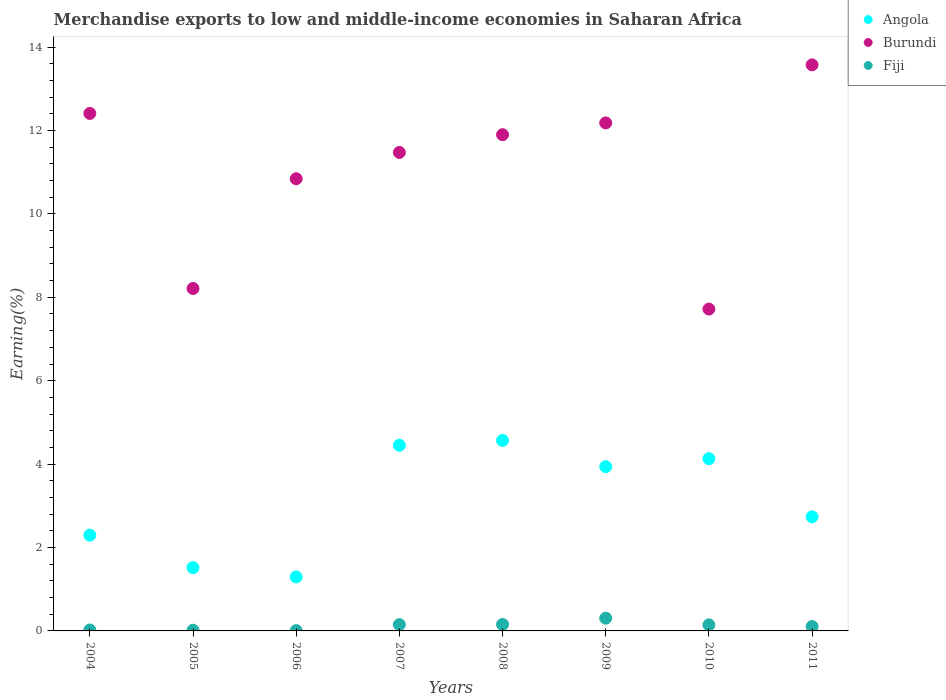What is the percentage of amount earned from merchandise exports in Fiji in 2009?
Your answer should be very brief. 0.31. Across all years, what is the maximum percentage of amount earned from merchandise exports in Fiji?
Ensure brevity in your answer.  0.31. Across all years, what is the minimum percentage of amount earned from merchandise exports in Fiji?
Give a very brief answer. 0.01. What is the total percentage of amount earned from merchandise exports in Fiji in the graph?
Offer a very short reply. 0.91. What is the difference between the percentage of amount earned from merchandise exports in Angola in 2005 and that in 2010?
Make the answer very short. -2.61. What is the difference between the percentage of amount earned from merchandise exports in Burundi in 2011 and the percentage of amount earned from merchandise exports in Fiji in 2007?
Your answer should be very brief. 13.42. What is the average percentage of amount earned from merchandise exports in Fiji per year?
Your answer should be very brief. 0.11. In the year 2007, what is the difference between the percentage of amount earned from merchandise exports in Angola and percentage of amount earned from merchandise exports in Burundi?
Make the answer very short. -7.02. What is the ratio of the percentage of amount earned from merchandise exports in Angola in 2004 to that in 2010?
Offer a very short reply. 0.56. What is the difference between the highest and the second highest percentage of amount earned from merchandise exports in Angola?
Offer a very short reply. 0.11. What is the difference between the highest and the lowest percentage of amount earned from merchandise exports in Fiji?
Your answer should be very brief. 0.3. In how many years, is the percentage of amount earned from merchandise exports in Angola greater than the average percentage of amount earned from merchandise exports in Angola taken over all years?
Your answer should be very brief. 4. Is it the case that in every year, the sum of the percentage of amount earned from merchandise exports in Fiji and percentage of amount earned from merchandise exports in Burundi  is greater than the percentage of amount earned from merchandise exports in Angola?
Your response must be concise. Yes. Does the percentage of amount earned from merchandise exports in Burundi monotonically increase over the years?
Your answer should be very brief. No. How many dotlines are there?
Give a very brief answer. 3. How many years are there in the graph?
Offer a terse response. 8. What is the difference between two consecutive major ticks on the Y-axis?
Ensure brevity in your answer.  2. Are the values on the major ticks of Y-axis written in scientific E-notation?
Your response must be concise. No. Where does the legend appear in the graph?
Keep it short and to the point. Top right. How are the legend labels stacked?
Offer a terse response. Vertical. What is the title of the graph?
Make the answer very short. Merchandise exports to low and middle-income economies in Saharan Africa. What is the label or title of the Y-axis?
Make the answer very short. Earning(%). What is the Earning(%) in Angola in 2004?
Keep it short and to the point. 2.3. What is the Earning(%) in Burundi in 2004?
Provide a succinct answer. 12.41. What is the Earning(%) in Fiji in 2004?
Provide a succinct answer. 0.02. What is the Earning(%) in Angola in 2005?
Provide a succinct answer. 1.52. What is the Earning(%) in Burundi in 2005?
Keep it short and to the point. 8.21. What is the Earning(%) of Fiji in 2005?
Your response must be concise. 0.02. What is the Earning(%) in Angola in 2006?
Provide a short and direct response. 1.3. What is the Earning(%) in Burundi in 2006?
Offer a terse response. 10.84. What is the Earning(%) in Fiji in 2006?
Keep it short and to the point. 0.01. What is the Earning(%) of Angola in 2007?
Provide a succinct answer. 4.45. What is the Earning(%) in Burundi in 2007?
Offer a very short reply. 11.47. What is the Earning(%) of Fiji in 2007?
Your response must be concise. 0.15. What is the Earning(%) in Angola in 2008?
Your answer should be very brief. 4.57. What is the Earning(%) in Burundi in 2008?
Ensure brevity in your answer.  11.9. What is the Earning(%) in Fiji in 2008?
Provide a short and direct response. 0.16. What is the Earning(%) of Angola in 2009?
Give a very brief answer. 3.94. What is the Earning(%) of Burundi in 2009?
Offer a terse response. 12.18. What is the Earning(%) of Fiji in 2009?
Your response must be concise. 0.31. What is the Earning(%) in Angola in 2010?
Keep it short and to the point. 4.13. What is the Earning(%) of Burundi in 2010?
Your answer should be very brief. 7.72. What is the Earning(%) of Fiji in 2010?
Provide a succinct answer. 0.15. What is the Earning(%) of Angola in 2011?
Your answer should be very brief. 2.74. What is the Earning(%) of Burundi in 2011?
Your response must be concise. 13.57. What is the Earning(%) of Fiji in 2011?
Your answer should be very brief. 0.11. Across all years, what is the maximum Earning(%) in Angola?
Offer a terse response. 4.57. Across all years, what is the maximum Earning(%) in Burundi?
Provide a succinct answer. 13.57. Across all years, what is the maximum Earning(%) of Fiji?
Your answer should be compact. 0.31. Across all years, what is the minimum Earning(%) in Angola?
Your answer should be compact. 1.3. Across all years, what is the minimum Earning(%) in Burundi?
Provide a succinct answer. 7.72. Across all years, what is the minimum Earning(%) of Fiji?
Your answer should be compact. 0.01. What is the total Earning(%) in Angola in the graph?
Keep it short and to the point. 24.94. What is the total Earning(%) in Burundi in the graph?
Your answer should be very brief. 88.31. What is the total Earning(%) in Fiji in the graph?
Provide a short and direct response. 0.91. What is the difference between the Earning(%) in Angola in 2004 and that in 2005?
Your response must be concise. 0.78. What is the difference between the Earning(%) of Burundi in 2004 and that in 2005?
Your answer should be compact. 4.2. What is the difference between the Earning(%) in Fiji in 2004 and that in 2005?
Provide a short and direct response. 0.01. What is the difference between the Earning(%) in Angola in 2004 and that in 2006?
Give a very brief answer. 1. What is the difference between the Earning(%) in Burundi in 2004 and that in 2006?
Your answer should be compact. 1.57. What is the difference between the Earning(%) in Fiji in 2004 and that in 2006?
Provide a succinct answer. 0.01. What is the difference between the Earning(%) of Angola in 2004 and that in 2007?
Keep it short and to the point. -2.16. What is the difference between the Earning(%) in Burundi in 2004 and that in 2007?
Your answer should be very brief. 0.94. What is the difference between the Earning(%) in Fiji in 2004 and that in 2007?
Make the answer very short. -0.13. What is the difference between the Earning(%) in Angola in 2004 and that in 2008?
Give a very brief answer. -2.27. What is the difference between the Earning(%) of Burundi in 2004 and that in 2008?
Give a very brief answer. 0.51. What is the difference between the Earning(%) in Fiji in 2004 and that in 2008?
Offer a very short reply. -0.13. What is the difference between the Earning(%) in Angola in 2004 and that in 2009?
Ensure brevity in your answer.  -1.64. What is the difference between the Earning(%) of Burundi in 2004 and that in 2009?
Your answer should be very brief. 0.23. What is the difference between the Earning(%) in Fiji in 2004 and that in 2009?
Your response must be concise. -0.28. What is the difference between the Earning(%) of Angola in 2004 and that in 2010?
Your response must be concise. -1.83. What is the difference between the Earning(%) in Burundi in 2004 and that in 2010?
Make the answer very short. 4.69. What is the difference between the Earning(%) in Fiji in 2004 and that in 2010?
Ensure brevity in your answer.  -0.12. What is the difference between the Earning(%) of Angola in 2004 and that in 2011?
Offer a very short reply. -0.44. What is the difference between the Earning(%) in Burundi in 2004 and that in 2011?
Provide a succinct answer. -1.17. What is the difference between the Earning(%) in Fiji in 2004 and that in 2011?
Offer a very short reply. -0.08. What is the difference between the Earning(%) in Angola in 2005 and that in 2006?
Your answer should be very brief. 0.22. What is the difference between the Earning(%) of Burundi in 2005 and that in 2006?
Your answer should be very brief. -2.63. What is the difference between the Earning(%) of Fiji in 2005 and that in 2006?
Ensure brevity in your answer.  0.01. What is the difference between the Earning(%) in Angola in 2005 and that in 2007?
Give a very brief answer. -2.93. What is the difference between the Earning(%) in Burundi in 2005 and that in 2007?
Provide a short and direct response. -3.26. What is the difference between the Earning(%) of Fiji in 2005 and that in 2007?
Give a very brief answer. -0.13. What is the difference between the Earning(%) in Angola in 2005 and that in 2008?
Your response must be concise. -3.05. What is the difference between the Earning(%) of Burundi in 2005 and that in 2008?
Provide a short and direct response. -3.69. What is the difference between the Earning(%) of Fiji in 2005 and that in 2008?
Your answer should be very brief. -0.14. What is the difference between the Earning(%) of Angola in 2005 and that in 2009?
Offer a very short reply. -2.42. What is the difference between the Earning(%) in Burundi in 2005 and that in 2009?
Offer a terse response. -3.97. What is the difference between the Earning(%) in Fiji in 2005 and that in 2009?
Ensure brevity in your answer.  -0.29. What is the difference between the Earning(%) in Angola in 2005 and that in 2010?
Give a very brief answer. -2.61. What is the difference between the Earning(%) of Burundi in 2005 and that in 2010?
Provide a succinct answer. 0.49. What is the difference between the Earning(%) of Fiji in 2005 and that in 2010?
Your answer should be compact. -0.13. What is the difference between the Earning(%) of Angola in 2005 and that in 2011?
Make the answer very short. -1.22. What is the difference between the Earning(%) in Burundi in 2005 and that in 2011?
Offer a very short reply. -5.36. What is the difference between the Earning(%) in Fiji in 2005 and that in 2011?
Give a very brief answer. -0.09. What is the difference between the Earning(%) in Angola in 2006 and that in 2007?
Your response must be concise. -3.16. What is the difference between the Earning(%) of Burundi in 2006 and that in 2007?
Give a very brief answer. -0.63. What is the difference between the Earning(%) in Fiji in 2006 and that in 2007?
Keep it short and to the point. -0.14. What is the difference between the Earning(%) of Angola in 2006 and that in 2008?
Offer a very short reply. -3.27. What is the difference between the Earning(%) of Burundi in 2006 and that in 2008?
Your answer should be compact. -1.06. What is the difference between the Earning(%) in Fiji in 2006 and that in 2008?
Ensure brevity in your answer.  -0.15. What is the difference between the Earning(%) of Angola in 2006 and that in 2009?
Offer a terse response. -2.64. What is the difference between the Earning(%) of Burundi in 2006 and that in 2009?
Make the answer very short. -1.34. What is the difference between the Earning(%) of Fiji in 2006 and that in 2009?
Provide a succinct answer. -0.3. What is the difference between the Earning(%) in Angola in 2006 and that in 2010?
Your response must be concise. -2.84. What is the difference between the Earning(%) in Burundi in 2006 and that in 2010?
Your response must be concise. 3.13. What is the difference between the Earning(%) of Fiji in 2006 and that in 2010?
Your answer should be compact. -0.14. What is the difference between the Earning(%) of Angola in 2006 and that in 2011?
Make the answer very short. -1.44. What is the difference between the Earning(%) of Burundi in 2006 and that in 2011?
Give a very brief answer. -2.73. What is the difference between the Earning(%) in Fiji in 2006 and that in 2011?
Your answer should be compact. -0.1. What is the difference between the Earning(%) in Angola in 2007 and that in 2008?
Ensure brevity in your answer.  -0.11. What is the difference between the Earning(%) in Burundi in 2007 and that in 2008?
Your answer should be compact. -0.43. What is the difference between the Earning(%) of Fiji in 2007 and that in 2008?
Provide a succinct answer. -0. What is the difference between the Earning(%) in Angola in 2007 and that in 2009?
Offer a very short reply. 0.51. What is the difference between the Earning(%) in Burundi in 2007 and that in 2009?
Keep it short and to the point. -0.71. What is the difference between the Earning(%) of Fiji in 2007 and that in 2009?
Provide a succinct answer. -0.15. What is the difference between the Earning(%) of Angola in 2007 and that in 2010?
Give a very brief answer. 0.32. What is the difference between the Earning(%) in Burundi in 2007 and that in 2010?
Offer a terse response. 3.76. What is the difference between the Earning(%) in Fiji in 2007 and that in 2010?
Your answer should be very brief. 0. What is the difference between the Earning(%) in Angola in 2007 and that in 2011?
Your answer should be compact. 1.72. What is the difference between the Earning(%) in Burundi in 2007 and that in 2011?
Keep it short and to the point. -2.1. What is the difference between the Earning(%) in Fiji in 2007 and that in 2011?
Make the answer very short. 0.05. What is the difference between the Earning(%) of Angola in 2008 and that in 2009?
Your answer should be very brief. 0.63. What is the difference between the Earning(%) of Burundi in 2008 and that in 2009?
Provide a short and direct response. -0.28. What is the difference between the Earning(%) in Angola in 2008 and that in 2010?
Your response must be concise. 0.44. What is the difference between the Earning(%) in Burundi in 2008 and that in 2010?
Your answer should be very brief. 4.18. What is the difference between the Earning(%) in Fiji in 2008 and that in 2010?
Your answer should be very brief. 0.01. What is the difference between the Earning(%) of Angola in 2008 and that in 2011?
Your answer should be compact. 1.83. What is the difference between the Earning(%) in Burundi in 2008 and that in 2011?
Offer a terse response. -1.67. What is the difference between the Earning(%) in Fiji in 2008 and that in 2011?
Ensure brevity in your answer.  0.05. What is the difference between the Earning(%) of Angola in 2009 and that in 2010?
Your response must be concise. -0.19. What is the difference between the Earning(%) in Burundi in 2009 and that in 2010?
Keep it short and to the point. 4.46. What is the difference between the Earning(%) in Fiji in 2009 and that in 2010?
Your response must be concise. 0.16. What is the difference between the Earning(%) in Angola in 2009 and that in 2011?
Provide a short and direct response. 1.2. What is the difference between the Earning(%) in Burundi in 2009 and that in 2011?
Your response must be concise. -1.39. What is the difference between the Earning(%) of Fiji in 2009 and that in 2011?
Your answer should be very brief. 0.2. What is the difference between the Earning(%) in Angola in 2010 and that in 2011?
Offer a terse response. 1.39. What is the difference between the Earning(%) in Burundi in 2010 and that in 2011?
Provide a succinct answer. -5.86. What is the difference between the Earning(%) in Fiji in 2010 and that in 2011?
Your answer should be compact. 0.04. What is the difference between the Earning(%) in Angola in 2004 and the Earning(%) in Burundi in 2005?
Offer a terse response. -5.92. What is the difference between the Earning(%) of Angola in 2004 and the Earning(%) of Fiji in 2005?
Give a very brief answer. 2.28. What is the difference between the Earning(%) in Burundi in 2004 and the Earning(%) in Fiji in 2005?
Your answer should be very brief. 12.39. What is the difference between the Earning(%) in Angola in 2004 and the Earning(%) in Burundi in 2006?
Offer a terse response. -8.55. What is the difference between the Earning(%) of Angola in 2004 and the Earning(%) of Fiji in 2006?
Your answer should be very brief. 2.29. What is the difference between the Earning(%) of Burundi in 2004 and the Earning(%) of Fiji in 2006?
Make the answer very short. 12.4. What is the difference between the Earning(%) of Angola in 2004 and the Earning(%) of Burundi in 2007?
Offer a very short reply. -9.18. What is the difference between the Earning(%) in Angola in 2004 and the Earning(%) in Fiji in 2007?
Make the answer very short. 2.15. What is the difference between the Earning(%) in Burundi in 2004 and the Earning(%) in Fiji in 2007?
Keep it short and to the point. 12.26. What is the difference between the Earning(%) of Angola in 2004 and the Earning(%) of Burundi in 2008?
Keep it short and to the point. -9.6. What is the difference between the Earning(%) of Angola in 2004 and the Earning(%) of Fiji in 2008?
Your response must be concise. 2.14. What is the difference between the Earning(%) of Burundi in 2004 and the Earning(%) of Fiji in 2008?
Provide a succinct answer. 12.25. What is the difference between the Earning(%) in Angola in 2004 and the Earning(%) in Burundi in 2009?
Your answer should be compact. -9.89. What is the difference between the Earning(%) of Angola in 2004 and the Earning(%) of Fiji in 2009?
Your answer should be very brief. 1.99. What is the difference between the Earning(%) in Burundi in 2004 and the Earning(%) in Fiji in 2009?
Offer a very short reply. 12.1. What is the difference between the Earning(%) of Angola in 2004 and the Earning(%) of Burundi in 2010?
Make the answer very short. -5.42. What is the difference between the Earning(%) of Angola in 2004 and the Earning(%) of Fiji in 2010?
Make the answer very short. 2.15. What is the difference between the Earning(%) of Burundi in 2004 and the Earning(%) of Fiji in 2010?
Your answer should be compact. 12.26. What is the difference between the Earning(%) in Angola in 2004 and the Earning(%) in Burundi in 2011?
Provide a short and direct response. -11.28. What is the difference between the Earning(%) of Angola in 2004 and the Earning(%) of Fiji in 2011?
Make the answer very short. 2.19. What is the difference between the Earning(%) of Burundi in 2004 and the Earning(%) of Fiji in 2011?
Provide a short and direct response. 12.3. What is the difference between the Earning(%) in Angola in 2005 and the Earning(%) in Burundi in 2006?
Ensure brevity in your answer.  -9.33. What is the difference between the Earning(%) in Angola in 2005 and the Earning(%) in Fiji in 2006?
Offer a terse response. 1.51. What is the difference between the Earning(%) of Burundi in 2005 and the Earning(%) of Fiji in 2006?
Offer a very short reply. 8.2. What is the difference between the Earning(%) of Angola in 2005 and the Earning(%) of Burundi in 2007?
Give a very brief answer. -9.96. What is the difference between the Earning(%) of Angola in 2005 and the Earning(%) of Fiji in 2007?
Offer a terse response. 1.37. What is the difference between the Earning(%) in Burundi in 2005 and the Earning(%) in Fiji in 2007?
Your response must be concise. 8.06. What is the difference between the Earning(%) in Angola in 2005 and the Earning(%) in Burundi in 2008?
Offer a terse response. -10.38. What is the difference between the Earning(%) of Angola in 2005 and the Earning(%) of Fiji in 2008?
Your response must be concise. 1.36. What is the difference between the Earning(%) in Burundi in 2005 and the Earning(%) in Fiji in 2008?
Your response must be concise. 8.06. What is the difference between the Earning(%) in Angola in 2005 and the Earning(%) in Burundi in 2009?
Provide a succinct answer. -10.66. What is the difference between the Earning(%) of Angola in 2005 and the Earning(%) of Fiji in 2009?
Your answer should be very brief. 1.21. What is the difference between the Earning(%) in Burundi in 2005 and the Earning(%) in Fiji in 2009?
Offer a very short reply. 7.91. What is the difference between the Earning(%) in Angola in 2005 and the Earning(%) in Burundi in 2010?
Offer a terse response. -6.2. What is the difference between the Earning(%) in Angola in 2005 and the Earning(%) in Fiji in 2010?
Offer a terse response. 1.37. What is the difference between the Earning(%) in Burundi in 2005 and the Earning(%) in Fiji in 2010?
Make the answer very short. 8.07. What is the difference between the Earning(%) in Angola in 2005 and the Earning(%) in Burundi in 2011?
Provide a succinct answer. -12.06. What is the difference between the Earning(%) of Angola in 2005 and the Earning(%) of Fiji in 2011?
Give a very brief answer. 1.41. What is the difference between the Earning(%) of Burundi in 2005 and the Earning(%) of Fiji in 2011?
Keep it short and to the point. 8.11. What is the difference between the Earning(%) of Angola in 2006 and the Earning(%) of Burundi in 2007?
Give a very brief answer. -10.18. What is the difference between the Earning(%) in Angola in 2006 and the Earning(%) in Fiji in 2007?
Make the answer very short. 1.14. What is the difference between the Earning(%) of Burundi in 2006 and the Earning(%) of Fiji in 2007?
Provide a short and direct response. 10.69. What is the difference between the Earning(%) in Angola in 2006 and the Earning(%) in Burundi in 2008?
Ensure brevity in your answer.  -10.6. What is the difference between the Earning(%) of Angola in 2006 and the Earning(%) of Fiji in 2008?
Make the answer very short. 1.14. What is the difference between the Earning(%) in Burundi in 2006 and the Earning(%) in Fiji in 2008?
Your response must be concise. 10.69. What is the difference between the Earning(%) of Angola in 2006 and the Earning(%) of Burundi in 2009?
Keep it short and to the point. -10.89. What is the difference between the Earning(%) in Burundi in 2006 and the Earning(%) in Fiji in 2009?
Keep it short and to the point. 10.54. What is the difference between the Earning(%) in Angola in 2006 and the Earning(%) in Burundi in 2010?
Provide a succinct answer. -6.42. What is the difference between the Earning(%) of Angola in 2006 and the Earning(%) of Fiji in 2010?
Provide a short and direct response. 1.15. What is the difference between the Earning(%) in Burundi in 2006 and the Earning(%) in Fiji in 2010?
Provide a short and direct response. 10.7. What is the difference between the Earning(%) of Angola in 2006 and the Earning(%) of Burundi in 2011?
Your answer should be compact. -12.28. What is the difference between the Earning(%) of Angola in 2006 and the Earning(%) of Fiji in 2011?
Provide a short and direct response. 1.19. What is the difference between the Earning(%) of Burundi in 2006 and the Earning(%) of Fiji in 2011?
Your answer should be very brief. 10.74. What is the difference between the Earning(%) in Angola in 2007 and the Earning(%) in Burundi in 2008?
Ensure brevity in your answer.  -7.45. What is the difference between the Earning(%) of Angola in 2007 and the Earning(%) of Fiji in 2008?
Provide a short and direct response. 4.3. What is the difference between the Earning(%) of Burundi in 2007 and the Earning(%) of Fiji in 2008?
Offer a very short reply. 11.32. What is the difference between the Earning(%) of Angola in 2007 and the Earning(%) of Burundi in 2009?
Keep it short and to the point. -7.73. What is the difference between the Earning(%) of Angola in 2007 and the Earning(%) of Fiji in 2009?
Provide a succinct answer. 4.15. What is the difference between the Earning(%) of Burundi in 2007 and the Earning(%) of Fiji in 2009?
Ensure brevity in your answer.  11.17. What is the difference between the Earning(%) of Angola in 2007 and the Earning(%) of Burundi in 2010?
Provide a short and direct response. -3.27. What is the difference between the Earning(%) of Angola in 2007 and the Earning(%) of Fiji in 2010?
Your answer should be very brief. 4.31. What is the difference between the Earning(%) in Burundi in 2007 and the Earning(%) in Fiji in 2010?
Your response must be concise. 11.33. What is the difference between the Earning(%) of Angola in 2007 and the Earning(%) of Burundi in 2011?
Make the answer very short. -9.12. What is the difference between the Earning(%) in Angola in 2007 and the Earning(%) in Fiji in 2011?
Provide a succinct answer. 4.35. What is the difference between the Earning(%) in Burundi in 2007 and the Earning(%) in Fiji in 2011?
Keep it short and to the point. 11.37. What is the difference between the Earning(%) in Angola in 2008 and the Earning(%) in Burundi in 2009?
Provide a succinct answer. -7.62. What is the difference between the Earning(%) in Angola in 2008 and the Earning(%) in Fiji in 2009?
Give a very brief answer. 4.26. What is the difference between the Earning(%) in Burundi in 2008 and the Earning(%) in Fiji in 2009?
Make the answer very short. 11.59. What is the difference between the Earning(%) in Angola in 2008 and the Earning(%) in Burundi in 2010?
Offer a terse response. -3.15. What is the difference between the Earning(%) in Angola in 2008 and the Earning(%) in Fiji in 2010?
Your answer should be very brief. 4.42. What is the difference between the Earning(%) of Burundi in 2008 and the Earning(%) of Fiji in 2010?
Make the answer very short. 11.75. What is the difference between the Earning(%) in Angola in 2008 and the Earning(%) in Burundi in 2011?
Keep it short and to the point. -9.01. What is the difference between the Earning(%) in Angola in 2008 and the Earning(%) in Fiji in 2011?
Offer a very short reply. 4.46. What is the difference between the Earning(%) in Burundi in 2008 and the Earning(%) in Fiji in 2011?
Your response must be concise. 11.79. What is the difference between the Earning(%) of Angola in 2009 and the Earning(%) of Burundi in 2010?
Offer a terse response. -3.78. What is the difference between the Earning(%) of Angola in 2009 and the Earning(%) of Fiji in 2010?
Make the answer very short. 3.79. What is the difference between the Earning(%) in Burundi in 2009 and the Earning(%) in Fiji in 2010?
Your answer should be very brief. 12.04. What is the difference between the Earning(%) of Angola in 2009 and the Earning(%) of Burundi in 2011?
Provide a short and direct response. -9.64. What is the difference between the Earning(%) of Angola in 2009 and the Earning(%) of Fiji in 2011?
Give a very brief answer. 3.83. What is the difference between the Earning(%) in Burundi in 2009 and the Earning(%) in Fiji in 2011?
Provide a succinct answer. 12.08. What is the difference between the Earning(%) in Angola in 2010 and the Earning(%) in Burundi in 2011?
Offer a very short reply. -9.44. What is the difference between the Earning(%) of Angola in 2010 and the Earning(%) of Fiji in 2011?
Provide a succinct answer. 4.03. What is the difference between the Earning(%) in Burundi in 2010 and the Earning(%) in Fiji in 2011?
Your answer should be very brief. 7.61. What is the average Earning(%) of Angola per year?
Offer a terse response. 3.12. What is the average Earning(%) in Burundi per year?
Your response must be concise. 11.04. What is the average Earning(%) in Fiji per year?
Ensure brevity in your answer.  0.11. In the year 2004, what is the difference between the Earning(%) of Angola and Earning(%) of Burundi?
Make the answer very short. -10.11. In the year 2004, what is the difference between the Earning(%) in Angola and Earning(%) in Fiji?
Your answer should be very brief. 2.27. In the year 2004, what is the difference between the Earning(%) of Burundi and Earning(%) of Fiji?
Ensure brevity in your answer.  12.39. In the year 2005, what is the difference between the Earning(%) in Angola and Earning(%) in Burundi?
Ensure brevity in your answer.  -6.69. In the year 2005, what is the difference between the Earning(%) of Angola and Earning(%) of Fiji?
Your response must be concise. 1.5. In the year 2005, what is the difference between the Earning(%) of Burundi and Earning(%) of Fiji?
Make the answer very short. 8.2. In the year 2006, what is the difference between the Earning(%) of Angola and Earning(%) of Burundi?
Provide a short and direct response. -9.55. In the year 2006, what is the difference between the Earning(%) of Angola and Earning(%) of Fiji?
Give a very brief answer. 1.29. In the year 2006, what is the difference between the Earning(%) in Burundi and Earning(%) in Fiji?
Make the answer very short. 10.84. In the year 2007, what is the difference between the Earning(%) of Angola and Earning(%) of Burundi?
Offer a terse response. -7.02. In the year 2007, what is the difference between the Earning(%) in Angola and Earning(%) in Fiji?
Provide a succinct answer. 4.3. In the year 2007, what is the difference between the Earning(%) in Burundi and Earning(%) in Fiji?
Provide a succinct answer. 11.32. In the year 2008, what is the difference between the Earning(%) in Angola and Earning(%) in Burundi?
Provide a short and direct response. -7.33. In the year 2008, what is the difference between the Earning(%) in Angola and Earning(%) in Fiji?
Offer a very short reply. 4.41. In the year 2008, what is the difference between the Earning(%) in Burundi and Earning(%) in Fiji?
Offer a terse response. 11.74. In the year 2009, what is the difference between the Earning(%) of Angola and Earning(%) of Burundi?
Ensure brevity in your answer.  -8.24. In the year 2009, what is the difference between the Earning(%) in Angola and Earning(%) in Fiji?
Provide a short and direct response. 3.63. In the year 2009, what is the difference between the Earning(%) of Burundi and Earning(%) of Fiji?
Provide a succinct answer. 11.88. In the year 2010, what is the difference between the Earning(%) of Angola and Earning(%) of Burundi?
Keep it short and to the point. -3.59. In the year 2010, what is the difference between the Earning(%) of Angola and Earning(%) of Fiji?
Offer a terse response. 3.98. In the year 2010, what is the difference between the Earning(%) of Burundi and Earning(%) of Fiji?
Provide a short and direct response. 7.57. In the year 2011, what is the difference between the Earning(%) of Angola and Earning(%) of Burundi?
Offer a terse response. -10.84. In the year 2011, what is the difference between the Earning(%) of Angola and Earning(%) of Fiji?
Offer a terse response. 2.63. In the year 2011, what is the difference between the Earning(%) of Burundi and Earning(%) of Fiji?
Keep it short and to the point. 13.47. What is the ratio of the Earning(%) in Angola in 2004 to that in 2005?
Your response must be concise. 1.51. What is the ratio of the Earning(%) of Burundi in 2004 to that in 2005?
Provide a short and direct response. 1.51. What is the ratio of the Earning(%) in Fiji in 2004 to that in 2005?
Offer a very short reply. 1.33. What is the ratio of the Earning(%) in Angola in 2004 to that in 2006?
Provide a short and direct response. 1.77. What is the ratio of the Earning(%) in Burundi in 2004 to that in 2006?
Offer a very short reply. 1.14. What is the ratio of the Earning(%) in Fiji in 2004 to that in 2006?
Make the answer very short. 3.03. What is the ratio of the Earning(%) of Angola in 2004 to that in 2007?
Provide a succinct answer. 0.52. What is the ratio of the Earning(%) in Burundi in 2004 to that in 2007?
Your response must be concise. 1.08. What is the ratio of the Earning(%) of Fiji in 2004 to that in 2007?
Your answer should be very brief. 0.15. What is the ratio of the Earning(%) in Angola in 2004 to that in 2008?
Keep it short and to the point. 0.5. What is the ratio of the Earning(%) of Burundi in 2004 to that in 2008?
Offer a terse response. 1.04. What is the ratio of the Earning(%) in Fiji in 2004 to that in 2008?
Ensure brevity in your answer.  0.14. What is the ratio of the Earning(%) of Angola in 2004 to that in 2009?
Provide a short and direct response. 0.58. What is the ratio of the Earning(%) of Burundi in 2004 to that in 2009?
Your response must be concise. 1.02. What is the ratio of the Earning(%) of Fiji in 2004 to that in 2009?
Your response must be concise. 0.07. What is the ratio of the Earning(%) of Angola in 2004 to that in 2010?
Offer a very short reply. 0.56. What is the ratio of the Earning(%) of Burundi in 2004 to that in 2010?
Give a very brief answer. 1.61. What is the ratio of the Earning(%) in Fiji in 2004 to that in 2010?
Keep it short and to the point. 0.15. What is the ratio of the Earning(%) in Angola in 2004 to that in 2011?
Offer a very short reply. 0.84. What is the ratio of the Earning(%) in Burundi in 2004 to that in 2011?
Make the answer very short. 0.91. What is the ratio of the Earning(%) of Fiji in 2004 to that in 2011?
Offer a terse response. 0.21. What is the ratio of the Earning(%) in Angola in 2005 to that in 2006?
Provide a succinct answer. 1.17. What is the ratio of the Earning(%) in Burundi in 2005 to that in 2006?
Give a very brief answer. 0.76. What is the ratio of the Earning(%) in Fiji in 2005 to that in 2006?
Keep it short and to the point. 2.28. What is the ratio of the Earning(%) of Angola in 2005 to that in 2007?
Your answer should be very brief. 0.34. What is the ratio of the Earning(%) in Burundi in 2005 to that in 2007?
Your response must be concise. 0.72. What is the ratio of the Earning(%) of Fiji in 2005 to that in 2007?
Keep it short and to the point. 0.11. What is the ratio of the Earning(%) in Angola in 2005 to that in 2008?
Offer a terse response. 0.33. What is the ratio of the Earning(%) in Burundi in 2005 to that in 2008?
Ensure brevity in your answer.  0.69. What is the ratio of the Earning(%) of Fiji in 2005 to that in 2008?
Ensure brevity in your answer.  0.11. What is the ratio of the Earning(%) of Angola in 2005 to that in 2009?
Give a very brief answer. 0.39. What is the ratio of the Earning(%) in Burundi in 2005 to that in 2009?
Your answer should be compact. 0.67. What is the ratio of the Earning(%) in Fiji in 2005 to that in 2009?
Your answer should be compact. 0.06. What is the ratio of the Earning(%) of Angola in 2005 to that in 2010?
Keep it short and to the point. 0.37. What is the ratio of the Earning(%) of Burundi in 2005 to that in 2010?
Make the answer very short. 1.06. What is the ratio of the Earning(%) of Fiji in 2005 to that in 2010?
Offer a terse response. 0.12. What is the ratio of the Earning(%) of Angola in 2005 to that in 2011?
Your response must be concise. 0.55. What is the ratio of the Earning(%) in Burundi in 2005 to that in 2011?
Provide a succinct answer. 0.6. What is the ratio of the Earning(%) in Fiji in 2005 to that in 2011?
Provide a succinct answer. 0.16. What is the ratio of the Earning(%) in Angola in 2006 to that in 2007?
Your answer should be compact. 0.29. What is the ratio of the Earning(%) of Burundi in 2006 to that in 2007?
Give a very brief answer. 0.95. What is the ratio of the Earning(%) of Fiji in 2006 to that in 2007?
Provide a short and direct response. 0.05. What is the ratio of the Earning(%) of Angola in 2006 to that in 2008?
Your response must be concise. 0.28. What is the ratio of the Earning(%) of Burundi in 2006 to that in 2008?
Provide a succinct answer. 0.91. What is the ratio of the Earning(%) in Fiji in 2006 to that in 2008?
Keep it short and to the point. 0.05. What is the ratio of the Earning(%) of Angola in 2006 to that in 2009?
Provide a short and direct response. 0.33. What is the ratio of the Earning(%) in Burundi in 2006 to that in 2009?
Your response must be concise. 0.89. What is the ratio of the Earning(%) in Fiji in 2006 to that in 2009?
Your response must be concise. 0.02. What is the ratio of the Earning(%) in Angola in 2006 to that in 2010?
Offer a very short reply. 0.31. What is the ratio of the Earning(%) of Burundi in 2006 to that in 2010?
Offer a very short reply. 1.41. What is the ratio of the Earning(%) in Fiji in 2006 to that in 2010?
Make the answer very short. 0.05. What is the ratio of the Earning(%) in Angola in 2006 to that in 2011?
Offer a very short reply. 0.47. What is the ratio of the Earning(%) of Burundi in 2006 to that in 2011?
Ensure brevity in your answer.  0.8. What is the ratio of the Earning(%) in Fiji in 2006 to that in 2011?
Provide a short and direct response. 0.07. What is the ratio of the Earning(%) of Angola in 2007 to that in 2008?
Give a very brief answer. 0.97. What is the ratio of the Earning(%) of Burundi in 2007 to that in 2008?
Make the answer very short. 0.96. What is the ratio of the Earning(%) of Fiji in 2007 to that in 2008?
Offer a very short reply. 0.97. What is the ratio of the Earning(%) in Angola in 2007 to that in 2009?
Provide a succinct answer. 1.13. What is the ratio of the Earning(%) in Burundi in 2007 to that in 2009?
Offer a terse response. 0.94. What is the ratio of the Earning(%) of Fiji in 2007 to that in 2009?
Your answer should be very brief. 0.49. What is the ratio of the Earning(%) in Angola in 2007 to that in 2010?
Your answer should be compact. 1.08. What is the ratio of the Earning(%) of Burundi in 2007 to that in 2010?
Ensure brevity in your answer.  1.49. What is the ratio of the Earning(%) in Fiji in 2007 to that in 2010?
Give a very brief answer. 1.03. What is the ratio of the Earning(%) of Angola in 2007 to that in 2011?
Offer a terse response. 1.63. What is the ratio of the Earning(%) of Burundi in 2007 to that in 2011?
Offer a very short reply. 0.85. What is the ratio of the Earning(%) in Fiji in 2007 to that in 2011?
Make the answer very short. 1.43. What is the ratio of the Earning(%) of Angola in 2008 to that in 2009?
Give a very brief answer. 1.16. What is the ratio of the Earning(%) of Burundi in 2008 to that in 2009?
Offer a very short reply. 0.98. What is the ratio of the Earning(%) in Fiji in 2008 to that in 2009?
Your answer should be compact. 0.51. What is the ratio of the Earning(%) in Angola in 2008 to that in 2010?
Give a very brief answer. 1.11. What is the ratio of the Earning(%) of Burundi in 2008 to that in 2010?
Provide a short and direct response. 1.54. What is the ratio of the Earning(%) in Fiji in 2008 to that in 2010?
Make the answer very short. 1.06. What is the ratio of the Earning(%) in Angola in 2008 to that in 2011?
Give a very brief answer. 1.67. What is the ratio of the Earning(%) in Burundi in 2008 to that in 2011?
Ensure brevity in your answer.  0.88. What is the ratio of the Earning(%) of Fiji in 2008 to that in 2011?
Offer a terse response. 1.47. What is the ratio of the Earning(%) in Angola in 2009 to that in 2010?
Your response must be concise. 0.95. What is the ratio of the Earning(%) in Burundi in 2009 to that in 2010?
Make the answer very short. 1.58. What is the ratio of the Earning(%) in Fiji in 2009 to that in 2010?
Provide a short and direct response. 2.09. What is the ratio of the Earning(%) in Angola in 2009 to that in 2011?
Your answer should be compact. 1.44. What is the ratio of the Earning(%) of Burundi in 2009 to that in 2011?
Provide a succinct answer. 0.9. What is the ratio of the Earning(%) of Fiji in 2009 to that in 2011?
Offer a terse response. 2.89. What is the ratio of the Earning(%) in Angola in 2010 to that in 2011?
Your answer should be compact. 1.51. What is the ratio of the Earning(%) of Burundi in 2010 to that in 2011?
Offer a very short reply. 0.57. What is the ratio of the Earning(%) in Fiji in 2010 to that in 2011?
Keep it short and to the point. 1.39. What is the difference between the highest and the second highest Earning(%) in Angola?
Provide a succinct answer. 0.11. What is the difference between the highest and the second highest Earning(%) in Burundi?
Provide a succinct answer. 1.17. What is the difference between the highest and the second highest Earning(%) of Fiji?
Offer a very short reply. 0.15. What is the difference between the highest and the lowest Earning(%) of Angola?
Provide a succinct answer. 3.27. What is the difference between the highest and the lowest Earning(%) in Burundi?
Your answer should be very brief. 5.86. What is the difference between the highest and the lowest Earning(%) in Fiji?
Your answer should be very brief. 0.3. 